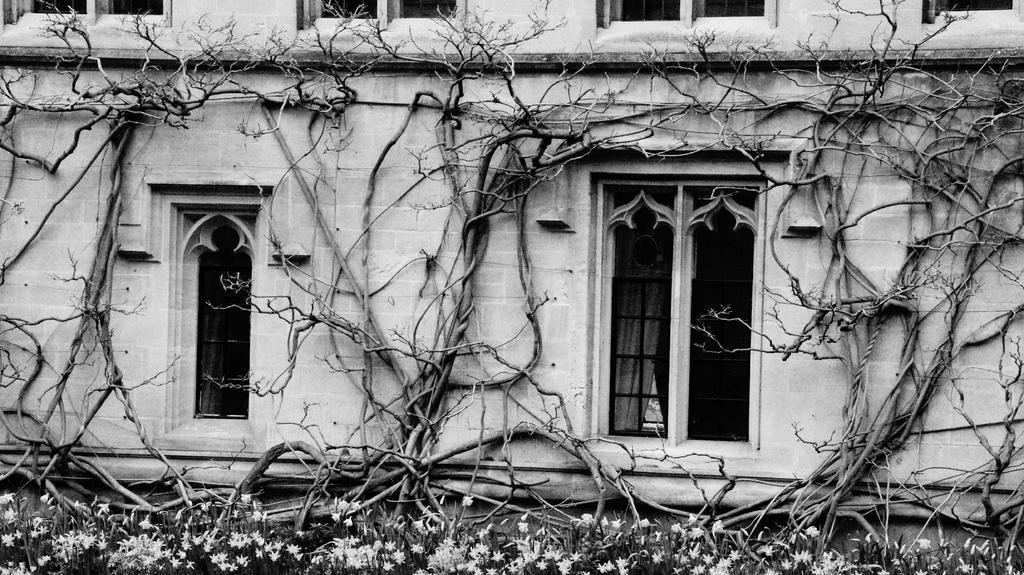In one or two sentences, can you explain what this image depicts? In this black and white image there is a building, in front of the buildings there are trees, flowers and plants. 